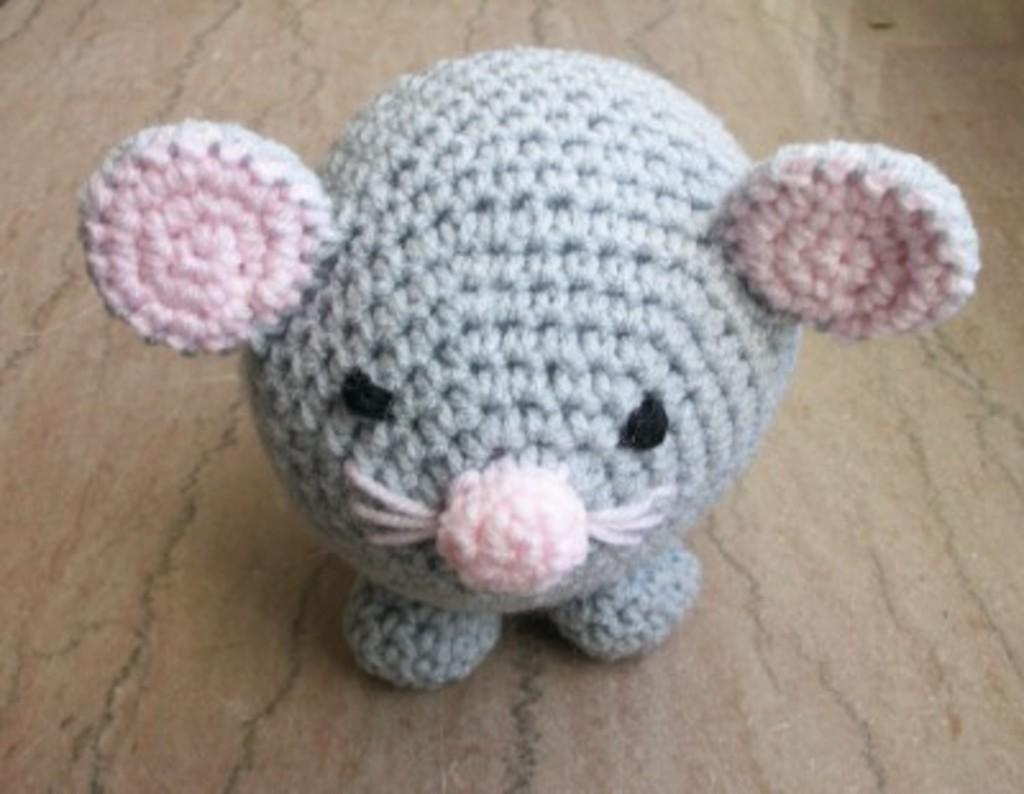What is the main subject of the image? There is a doll in the image. Where is the doll placed? The doll is placed on a marble platform. What grade did the doll receive on its last report card? Dolls do not receive report cards or grades, as they are inanimate objects and not students. 